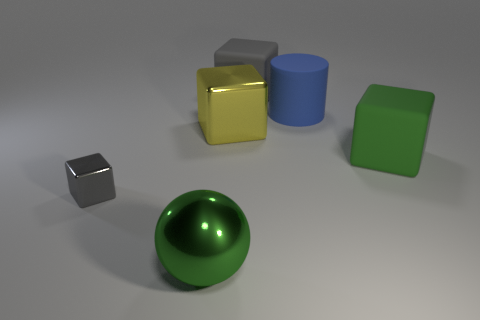Is there any other thing that is the same color as the tiny shiny block?
Make the answer very short. Yes. There is a small gray object that is the same material as the yellow thing; what is its shape?
Provide a short and direct response. Cube. What is the material of the yellow block on the left side of the big cube that is in front of the yellow block?
Offer a terse response. Metal. There is a big green object that is in front of the gray shiny thing; does it have the same shape as the green rubber thing?
Your answer should be compact. No. Is the number of small gray shiny cubes behind the big yellow cube greater than the number of tiny gray rubber cubes?
Provide a succinct answer. No. Is there any other thing that is the same material as the big green ball?
Ensure brevity in your answer.  Yes. There is a rubber thing that is the same color as the large metal sphere; what is its shape?
Keep it short and to the point. Cube. How many spheres are blue matte objects or large green metallic objects?
Give a very brief answer. 1. There is a shiny object that is behind the big matte cube that is right of the big gray rubber thing; what color is it?
Your answer should be compact. Yellow. There is a large metal block; does it have the same color as the large metallic thing that is in front of the tiny gray shiny block?
Provide a succinct answer. No. 